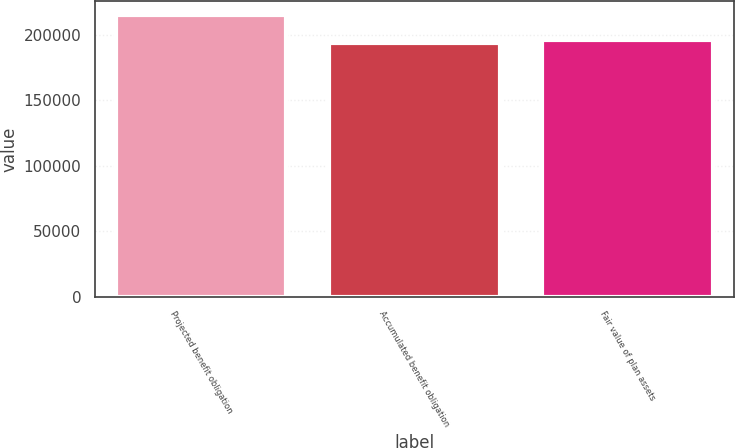Convert chart to OTSL. <chart><loc_0><loc_0><loc_500><loc_500><bar_chart><fcel>Projected benefit obligation<fcel>Accumulated benefit obligation<fcel>Fair value of plan assets<nl><fcel>214805<fcel>193421<fcel>195966<nl></chart> 